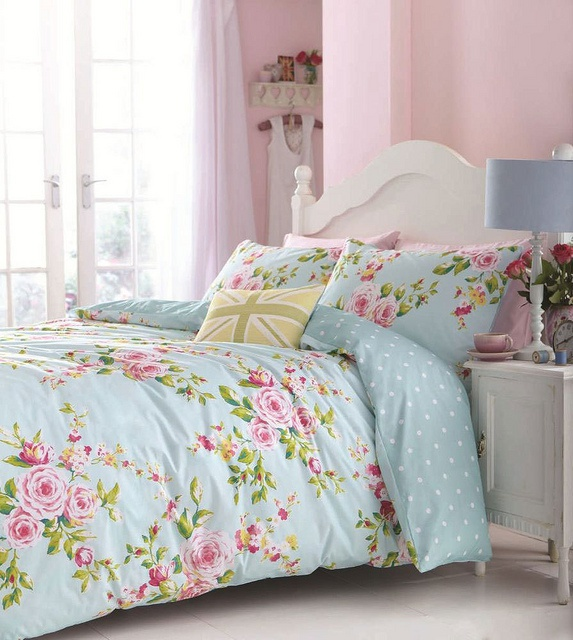Describe the objects in this image and their specific colors. I can see bed in white, lightgray, darkgray, lightblue, and tan tones, cup in white, gray, brown, darkgray, and maroon tones, clock in white, gray, and black tones, vase in white, gray, and black tones, and vase in white, gray, and black tones in this image. 